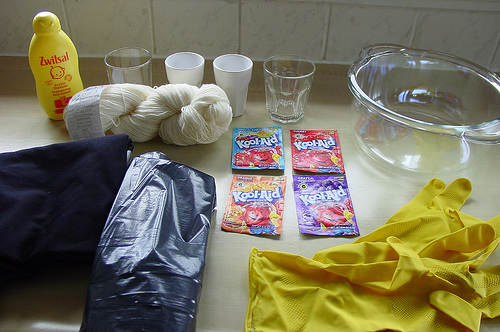<image>
Is there a koolaid in the bowl? No. The koolaid is not contained within the bowl. These objects have a different spatial relationship. Is the glass above the kitchen counter? No. The glass is not positioned above the kitchen counter. The vertical arrangement shows a different relationship. 